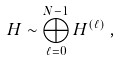<formula> <loc_0><loc_0><loc_500><loc_500>H \sim \bigoplus _ { \ell = 0 } ^ { N - 1 } H ^ { ( \ell ) } \, ,</formula> 